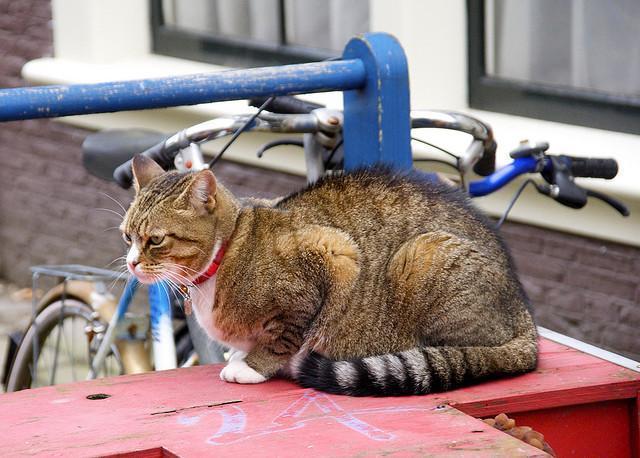How many bicycles are there?
Give a very brief answer. 2. How many hospital beds are there?
Give a very brief answer. 0. 